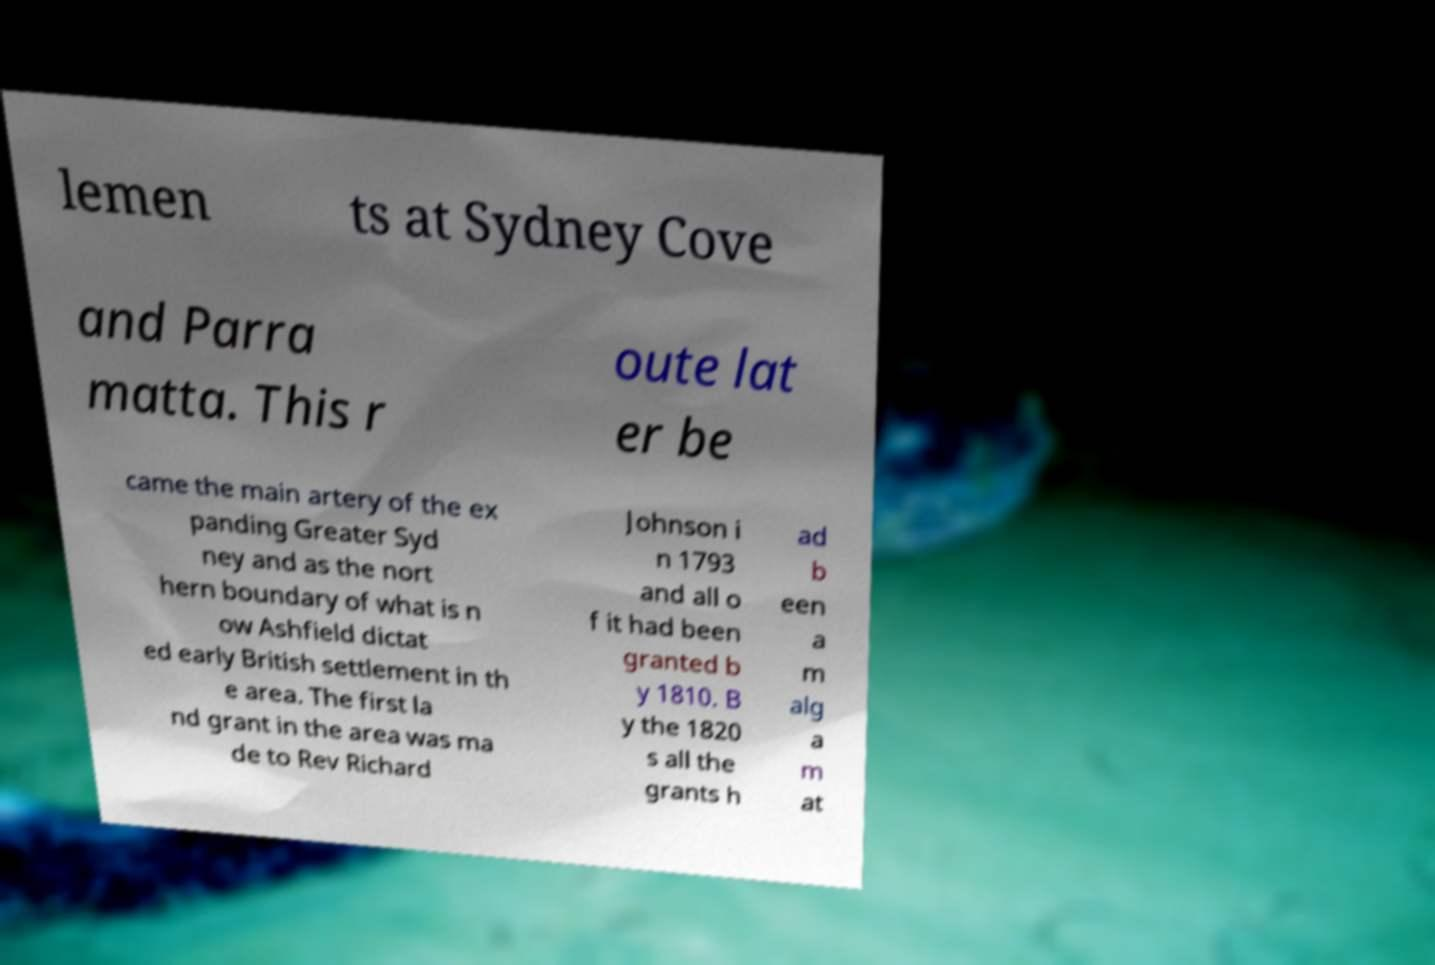There's text embedded in this image that I need extracted. Can you transcribe it verbatim? lemen ts at Sydney Cove and Parra matta. This r oute lat er be came the main artery of the ex panding Greater Syd ney and as the nort hern boundary of what is n ow Ashfield dictat ed early British settlement in th e area. The first la nd grant in the area was ma de to Rev Richard Johnson i n 1793 and all o f it had been granted b y 1810. B y the 1820 s all the grants h ad b een a m alg a m at 